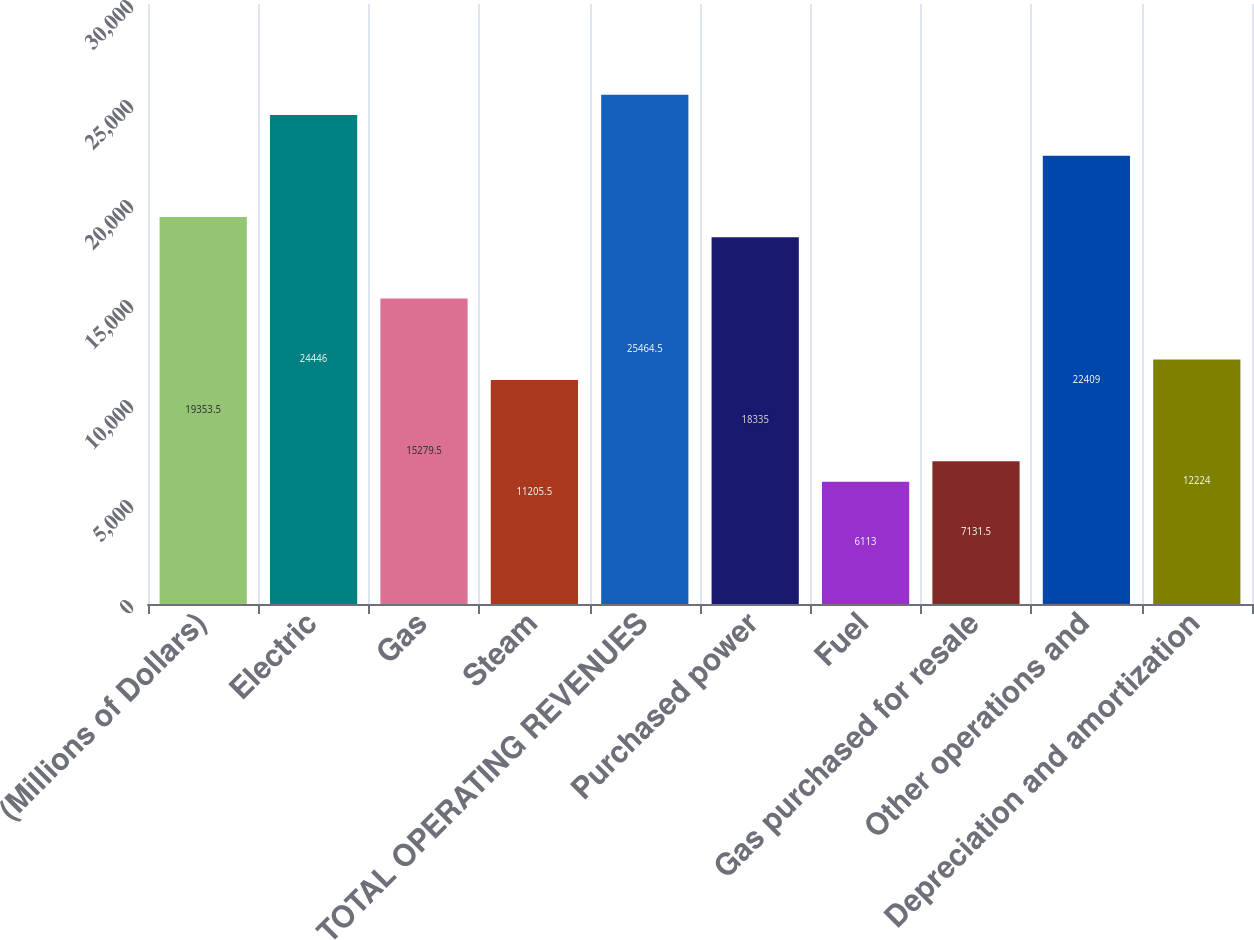<chart> <loc_0><loc_0><loc_500><loc_500><bar_chart><fcel>(Millions of Dollars)<fcel>Electric<fcel>Gas<fcel>Steam<fcel>TOTAL OPERATING REVENUES<fcel>Purchased power<fcel>Fuel<fcel>Gas purchased for resale<fcel>Other operations and<fcel>Depreciation and amortization<nl><fcel>19353.5<fcel>24446<fcel>15279.5<fcel>11205.5<fcel>25464.5<fcel>18335<fcel>6113<fcel>7131.5<fcel>22409<fcel>12224<nl></chart> 